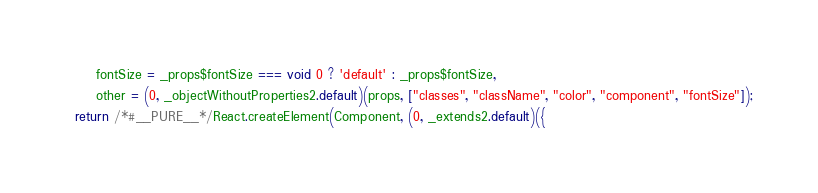<code> <loc_0><loc_0><loc_500><loc_500><_JavaScript_>      fontSize = _props$fontSize === void 0 ? 'default' : _props$fontSize,
      other = (0, _objectWithoutProperties2.default)(props, ["classes", "className", "color", "component", "fontSize"]);
  return /*#__PURE__*/React.createElement(Component, (0, _extends2.default)({</code> 